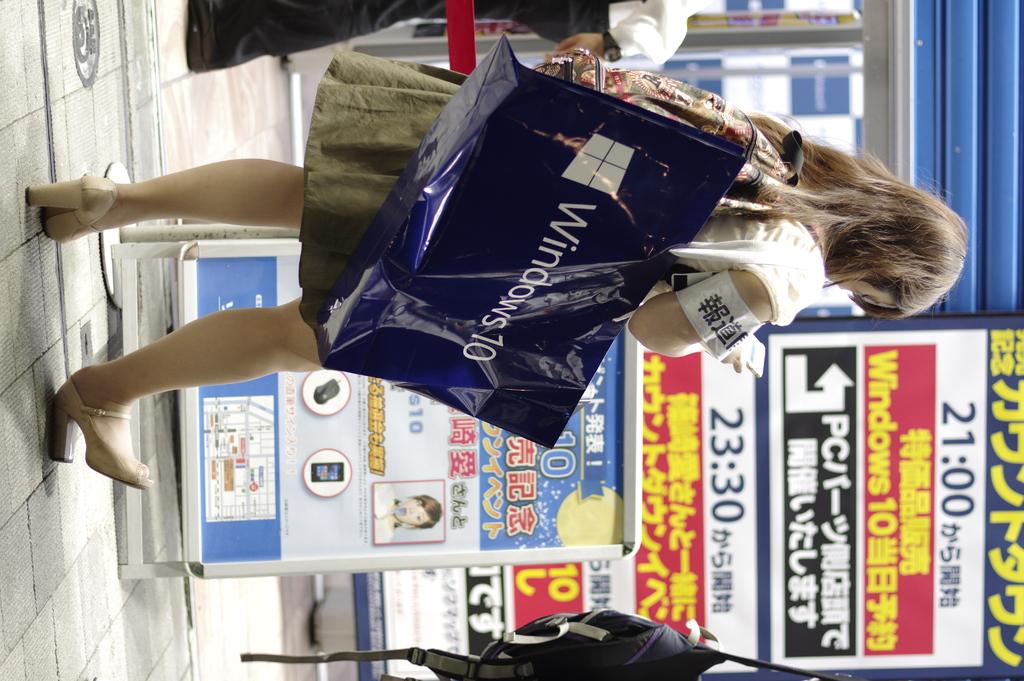What operating system is referenced on her bag?
Give a very brief answer. Windows 10. What time does it say on the top of the sign?
Provide a succinct answer. 21:00. 